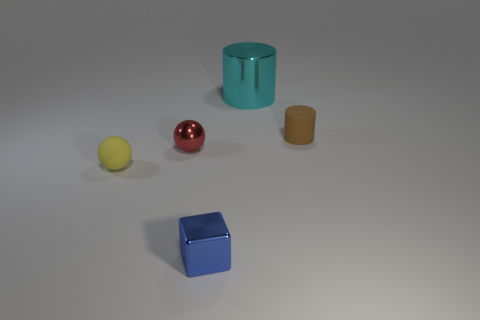Can you tell me which objects in the image are likely to weigh more based on their size and the material they appear to be made from? Based on the size and materials apparent in the image, the big metal cylinder and the blue cube likely weigh more than the smaller objects. Metal typically has a higher density than materials such as plastic or rubber, which the smaller objects might be made from. 